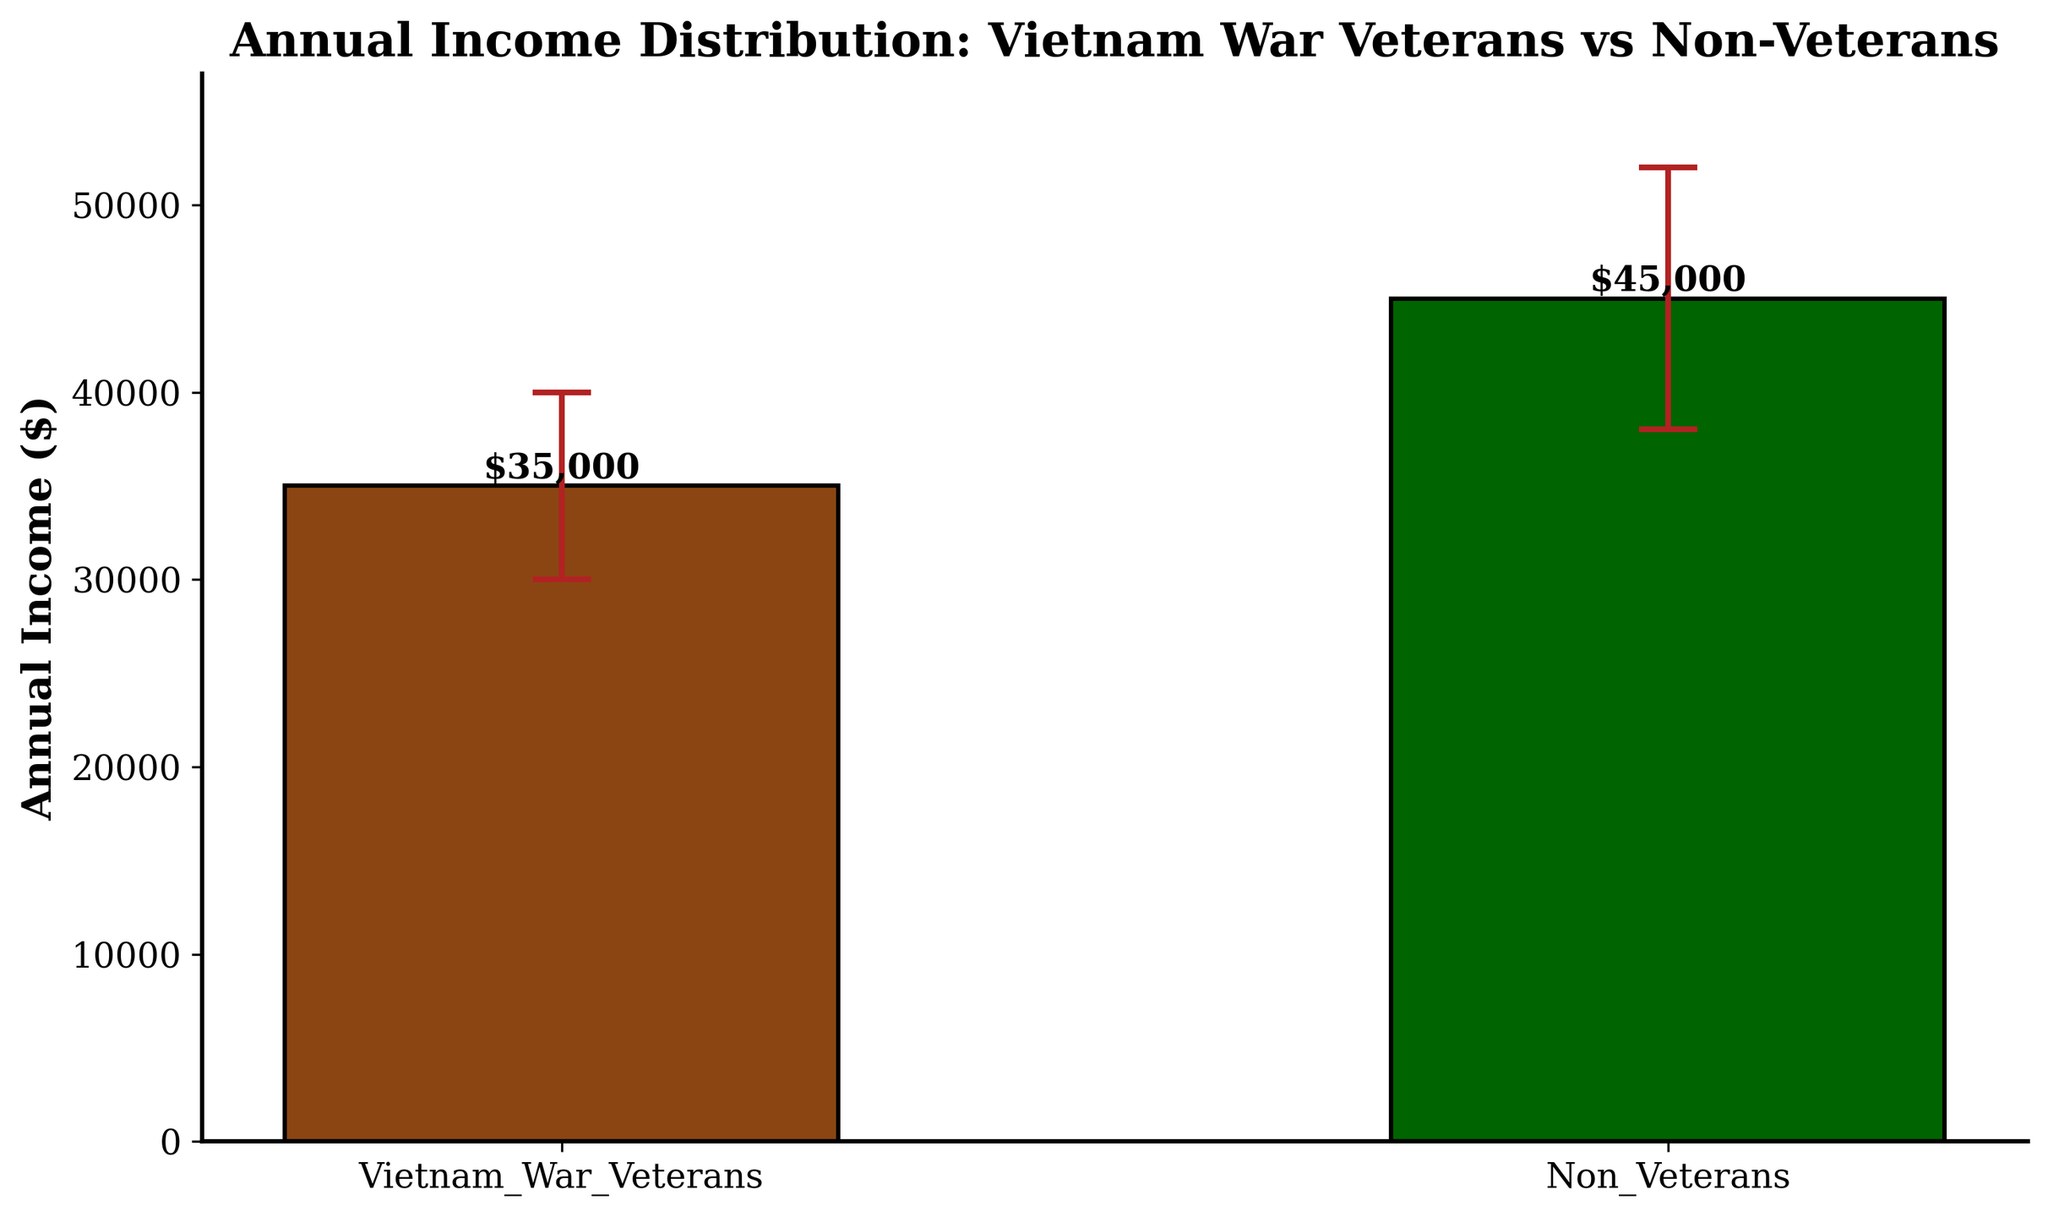What's the title of the chart? The title is displayed at the top of the chart in larger and bold text.
Answer: Annual Income Distribution: Vietnam War Veterans vs Non-Veterans What are the categories compared in the chart? The categories can be identified from the labels on the x-axis or the legend in the chart.
Answer: Vietnam War Veterans, Non-Veterans What is the mean annual income for Vietnam War veterans? The mean annual income for Vietnam War veterans is given by the height of the bar representing this category.
Answer: $35,000 Which group has a higher mean annual income? By comparing the heights of the bars, we can see which bar is taller. The Non-Veterans bar is taller.
Answer: Non-Veterans What is the mean income difference between the two groups? Subtract the mean income of Vietnam War veterans from the mean income of Non-Veterans. ($45,000 - $35,000)
Answer: $10,000 What does the y-axis represent? The y-axis label shows what the axis measures, which is mean annual income in dollars.
Answer: Annual Income ($) What are the standard deviations for each category? The standard deviations can be determined by the error bars' length, or directly from the data labels if provided.
Answer: Veterans: $5,000, Non-Veterans: $7,000 What is the highest mean annual income shown in the chart? The highest mean annual income is indicated by the tallest bar in the chart.
Answer: $45,000 How do the error bars of the two categories compare? Observe the length of the error bars for each category to determine their relative sizes. The error bar for Non-Veterans is longer, indicating a higher standard deviation.
Answer: The error bar for Non-Veterans is longer If you combine both groups, what would be the average mean income? Add the mean incomes of both groups and divide by 2. ($35,000 + $45,000) / 2
Answer: $40,000 